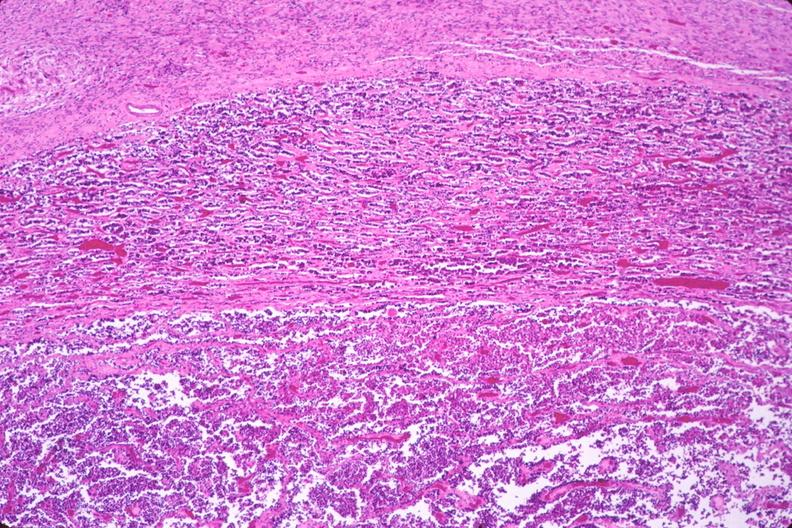does aorta show pituitary, chromaphobe adenoma?
Answer the question using a single word or phrase. No 